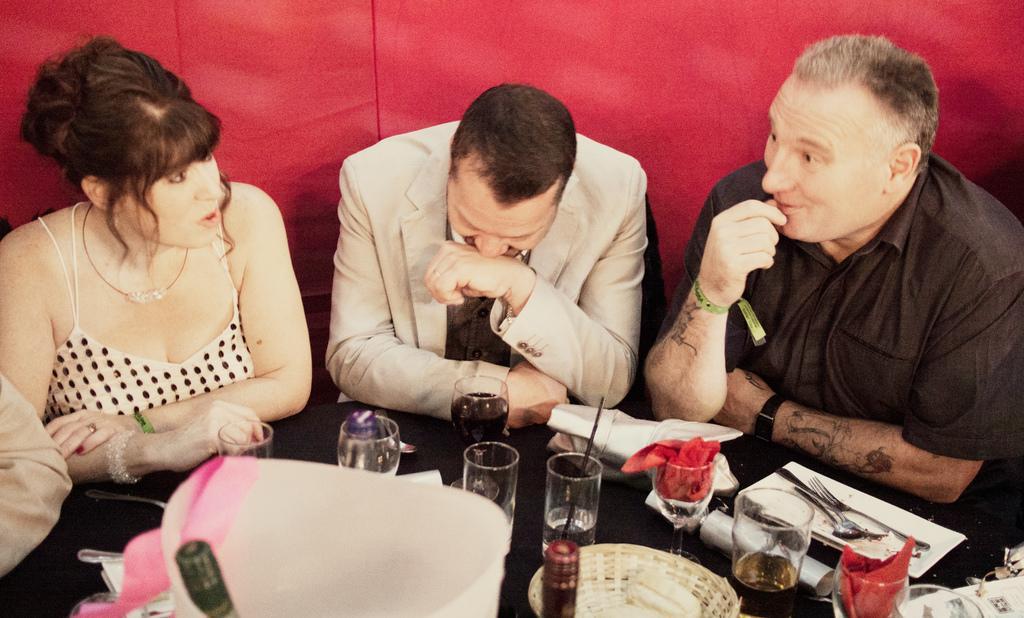Describe this image in one or two sentences. In this picture, we see four people sitting on the chairs around the table. The man in the black shirt is talking to the woman who is wearing a white dress. In front of them, we see a table on which water glass, glass containing cool drink, tray, spoon, fork and tissue papers are placed. Behind them, we see a red color sheet. 